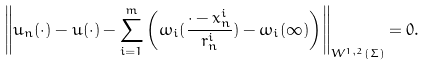Convert formula to latex. <formula><loc_0><loc_0><loc_500><loc_500>\left \| u _ { n } ( \cdot ) - u ( \cdot ) - \sum _ { i = 1 } ^ { m } \left ( \omega _ { i } ( \frac { \cdot - x _ { n } ^ { i } } { r _ { n } ^ { i } } ) - \omega _ { i } ( \infty ) \right ) \right \| _ { W ^ { 1 , 2 } ( \Sigma ) } = 0 .</formula> 